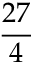<formula> <loc_0><loc_0><loc_500><loc_500>\frac { 2 7 } { 4 }</formula> 